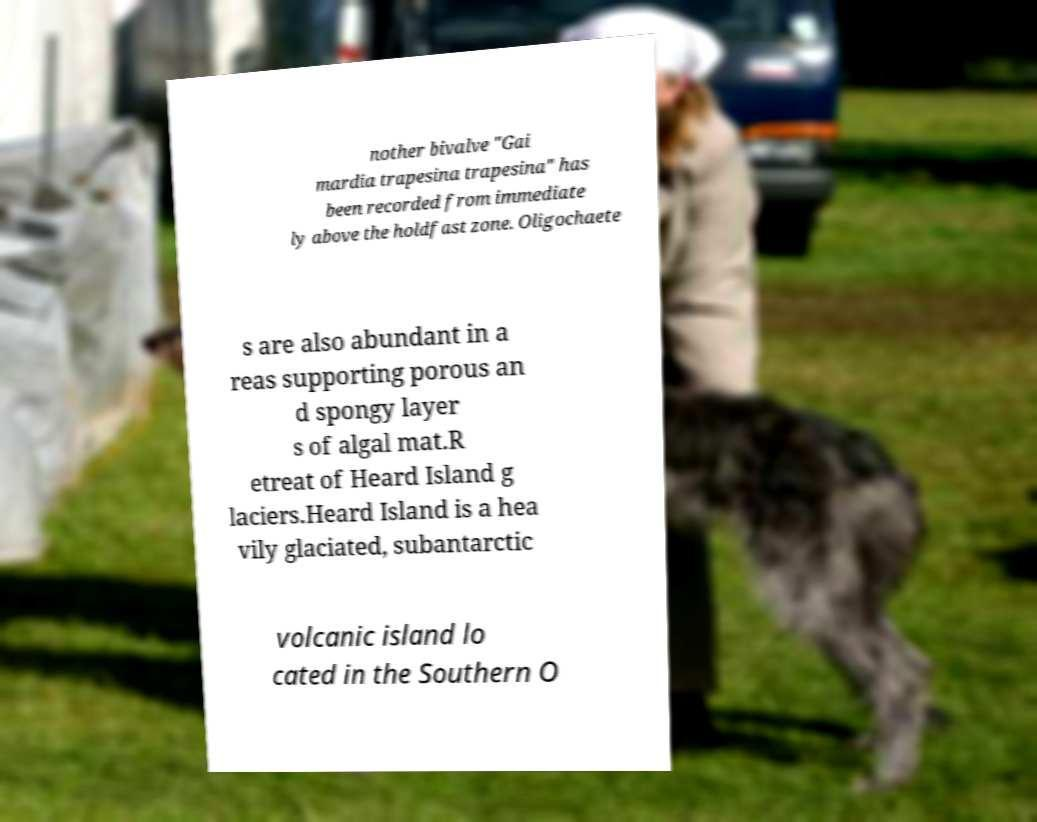Could you extract and type out the text from this image? nother bivalve "Gai mardia trapesina trapesina" has been recorded from immediate ly above the holdfast zone. Oligochaete s are also abundant in a reas supporting porous an d spongy layer s of algal mat.R etreat of Heard Island g laciers.Heard Island is a hea vily glaciated, subantarctic volcanic island lo cated in the Southern O 